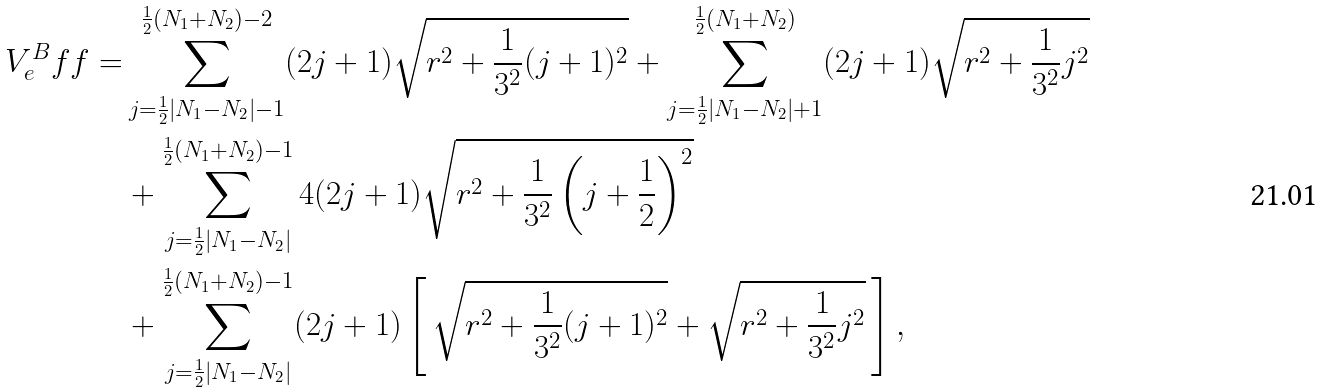Convert formula to latex. <formula><loc_0><loc_0><loc_500><loc_500>V ^ { B } _ { e } f f = & \sum ^ { \frac { 1 } { 2 } ( N _ { 1 } + N _ { 2 } ) - 2 } _ { j = \frac { 1 } { 2 } | N _ { 1 } - N _ { 2 } | - 1 } ( 2 j + 1 ) \sqrt { r ^ { 2 } + \frac { 1 } { 3 ^ { 2 } } ( j + 1 ) ^ { 2 } } + \sum ^ { \frac { 1 } { 2 } ( N _ { 1 } + N _ { 2 } ) } _ { j = \frac { 1 } { 2 } | N _ { 1 } - N _ { 2 } | + 1 } ( 2 j + 1 ) \sqrt { r ^ { 2 } + \frac { 1 } { 3 ^ { 2 } } j ^ { 2 } } \\ & + \sum ^ { \frac { 1 } { 2 } ( N _ { 1 } + N _ { 2 } ) - 1 } _ { j = \frac { 1 } { 2 } | N _ { 1 } - N _ { 2 } | } 4 ( 2 j + 1 ) \sqrt { r ^ { 2 } + \frac { 1 } { 3 ^ { 2 } } \left ( j + \frac { 1 } { 2 } \right ) ^ { 2 } } \\ & + \sum ^ { \frac { 1 } { 2 } ( N _ { 1 } + N _ { 2 } ) - 1 } _ { j = \frac { 1 } { 2 } | N _ { 1 } - N _ { 2 } | } ( 2 j + 1 ) \left [ \, \sqrt { r ^ { 2 } + \frac { 1 } { 3 ^ { 2 } } ( j + 1 ) ^ { 2 } } + \sqrt { r ^ { 2 } + \frac { 1 } { 3 ^ { 2 } } j ^ { 2 } } \, \right ] ,</formula> 